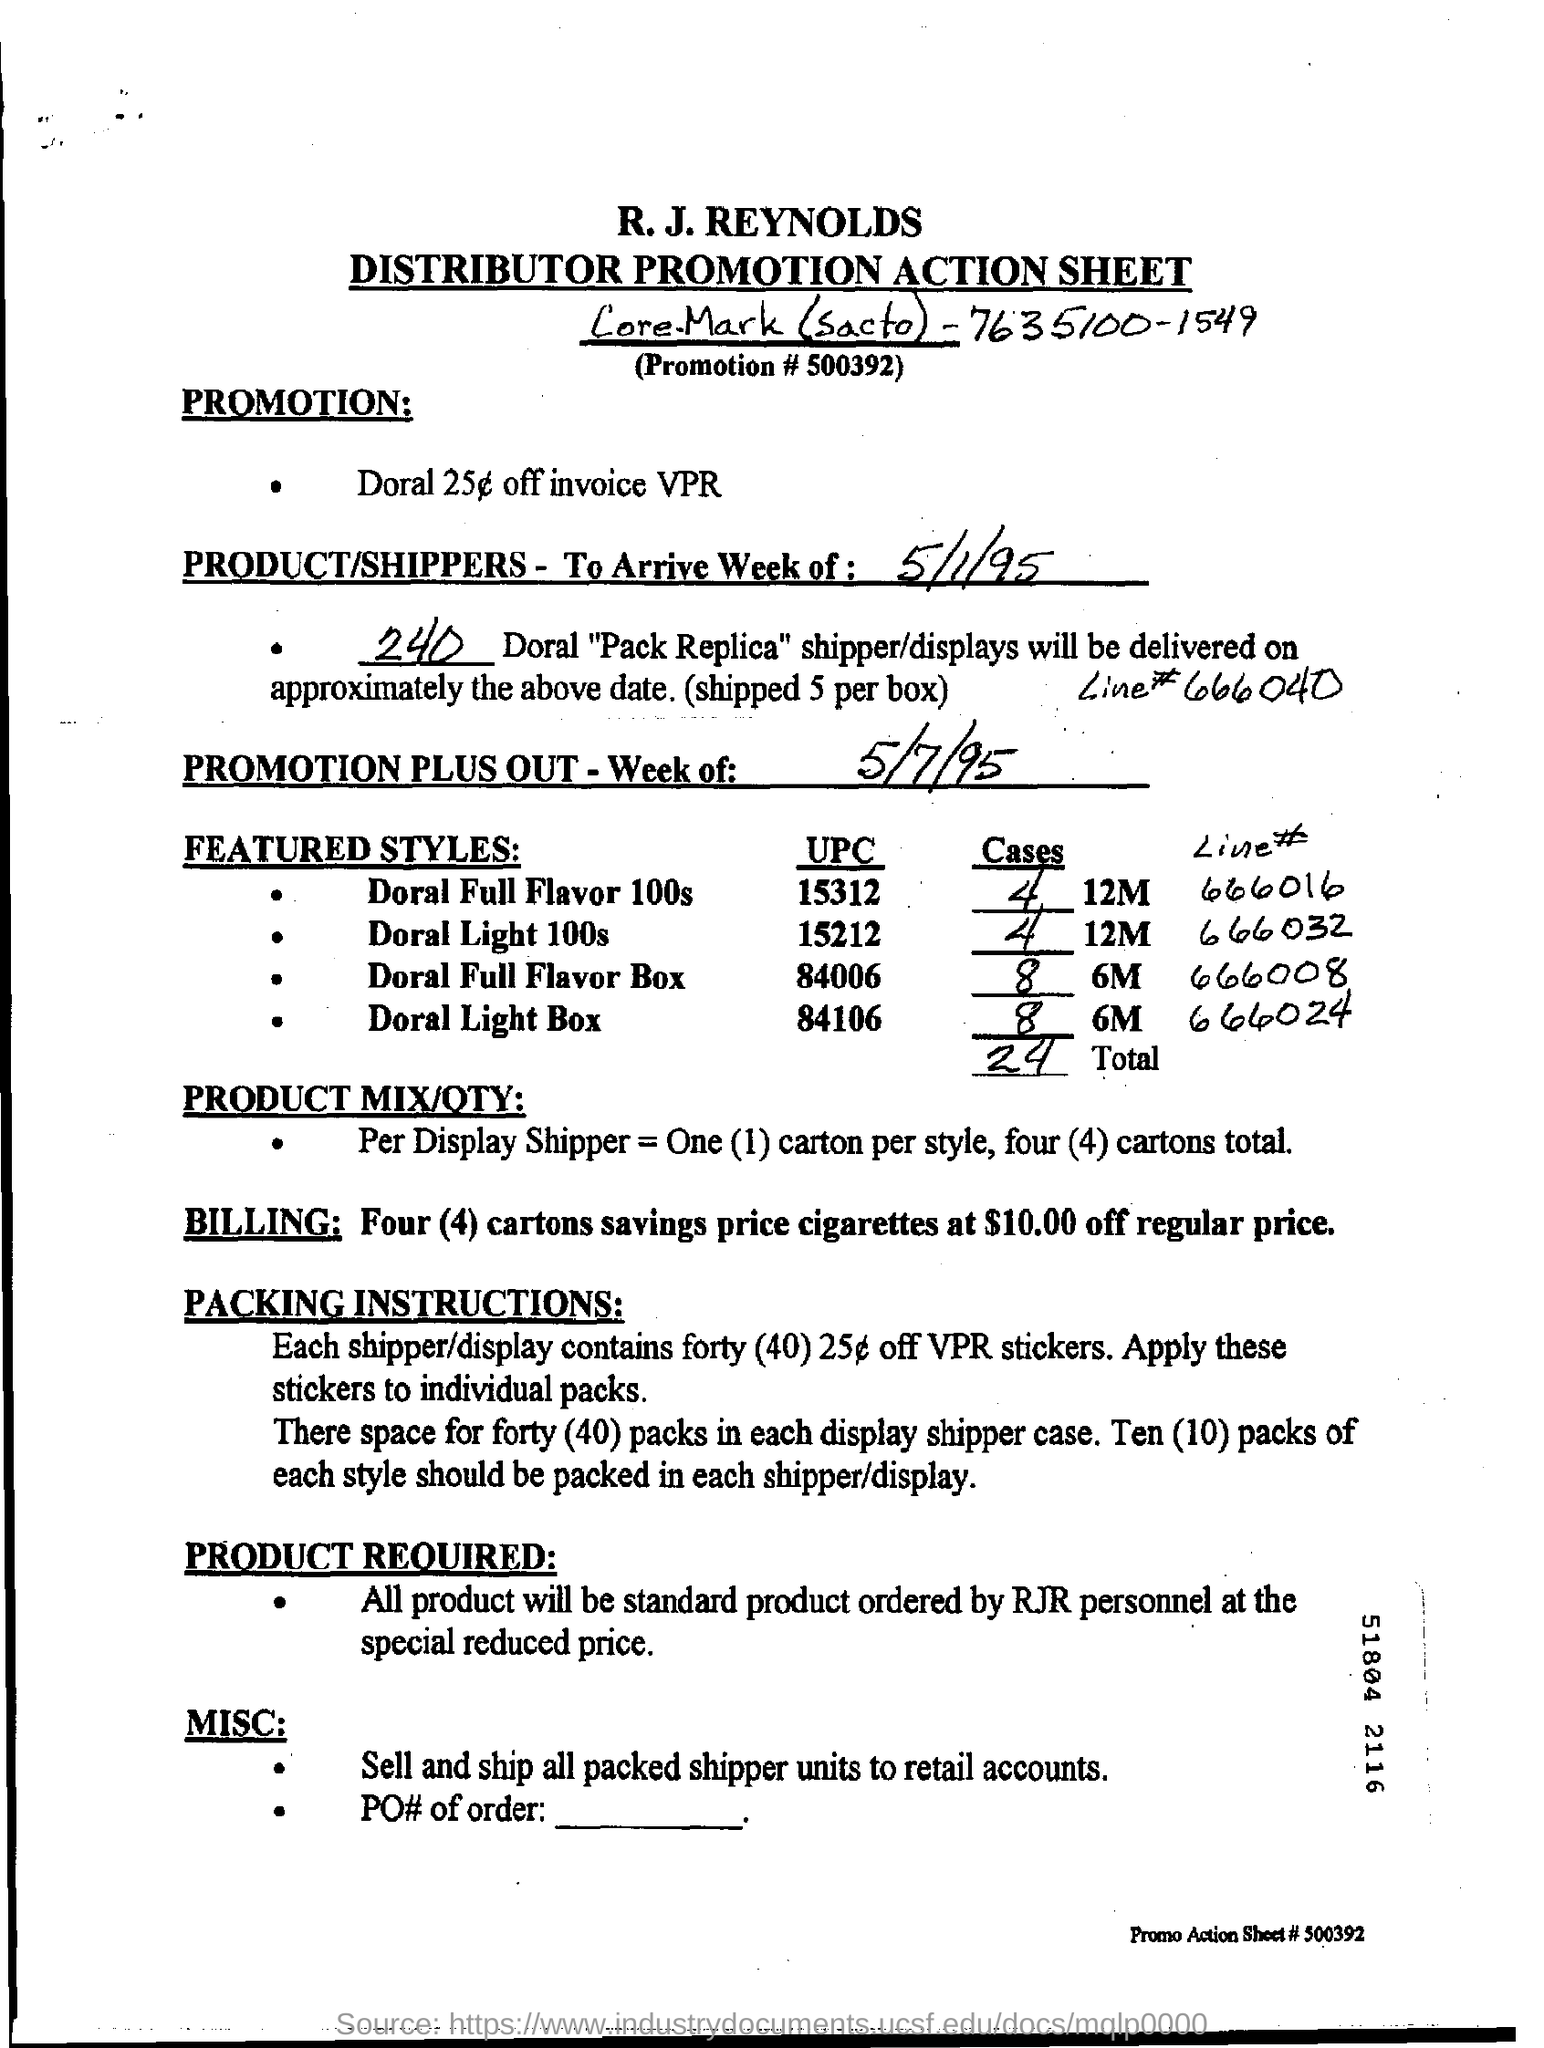What is the promotion number?
Keep it short and to the point. 500392. How many Doral "Pack Replica" shipper/displays will be delivered?
Provide a succinct answer. 240. What is the promotion?
Keep it short and to the point. Doral 25c off invoice VPR. How many 25 c off VPR stickers does each shipper/display contain?
Offer a very short reply. 40. Who will order standard product at special reduced price?
Make the answer very short. Rjr personnel. 